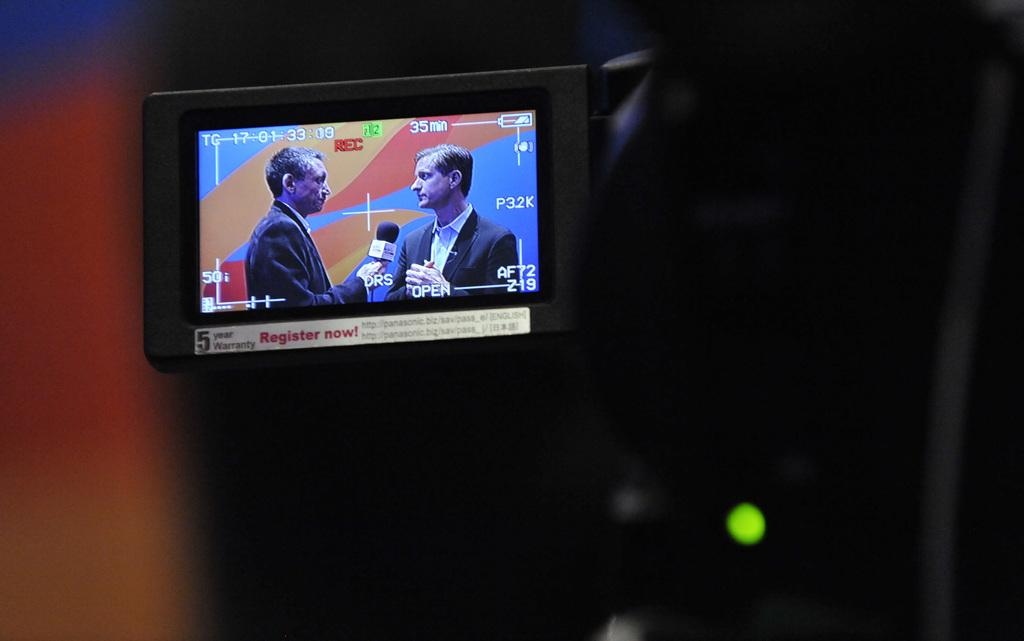<image>
Render a clear and concise summary of the photo. Someone video recording two people giving an interview for 35 minutes. 